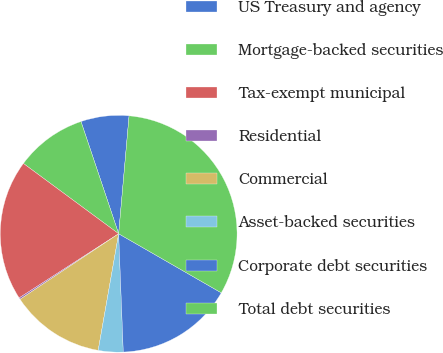<chart> <loc_0><loc_0><loc_500><loc_500><pie_chart><fcel>US Treasury and agency<fcel>Mortgage-backed securities<fcel>Tax-exempt municipal<fcel>Residential<fcel>Commercial<fcel>Asset-backed securities<fcel>Corporate debt securities<fcel>Total debt securities<nl><fcel>6.56%<fcel>9.73%<fcel>19.24%<fcel>0.22%<fcel>12.9%<fcel>3.39%<fcel>16.07%<fcel>31.92%<nl></chart> 